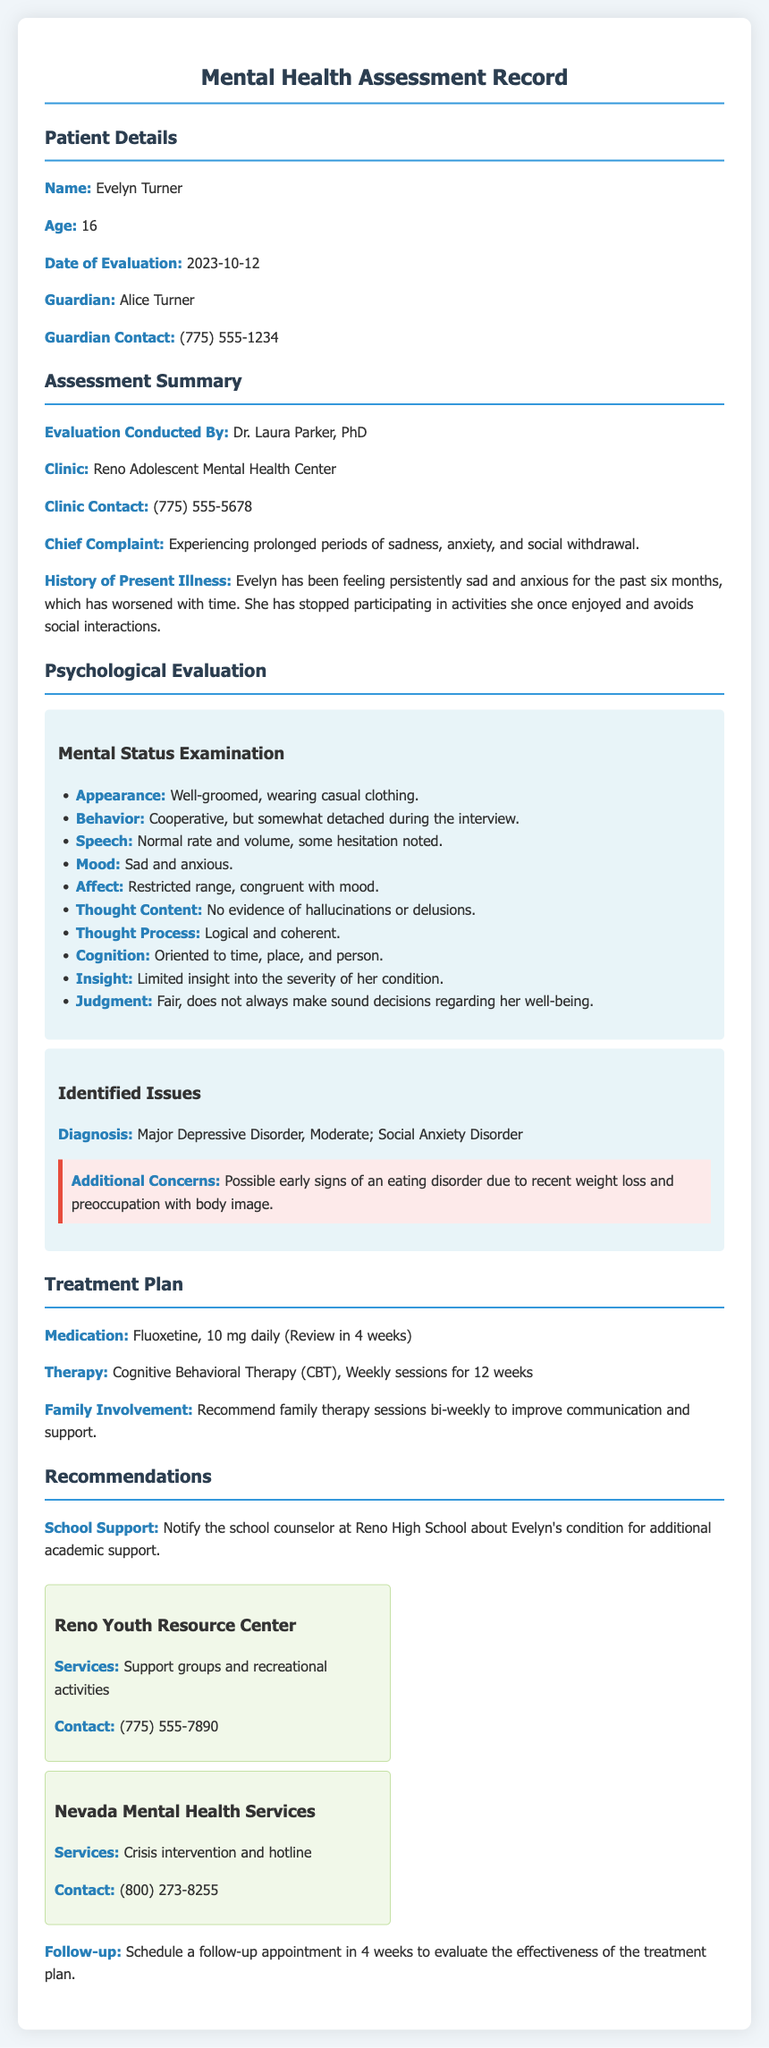What is the patient's name? The patient's name is listed at the beginning of the document under Patient Details.
Answer: Evelyn Turner What is the age of the patient? The patient's age can be found in the Patient Details section.
Answer: 16 Who conducted the evaluation? The evaluator's name is mentioned in the Assessment Summary section.
Answer: Dr. Laura Parker, PhD What is the chief complaint of the patient? The chief complaint is outlined in the Assessment Summary under Chief Complaint.
Answer: Experiencing prolonged periods of sadness, anxiety, and social withdrawal What diagnosis was given to the patient? The diagnosis is found in the Identified Issues subsection of the Psychological Evaluation.
Answer: Major Depressive Disorder, Moderate; Social Anxiety Disorder What medication is prescribed? The prescribed medication is specified in the Treatment Plan section.
Answer: Fluoxetine, 10 mg daily How many therapy sessions are recommended? The number of therapy sessions is described in the Treatment Plan section.
Answer: 12 weeks What is one resource available in the Reno community? A resource listed in Recommendations can be found under the relevant subsection.
Answer: Reno Youth Resource Center What follow-up is scheduled? The follow-up details are provided in the Recommendations section.
Answer: Schedule a follow-up appointment in 4 weeks 